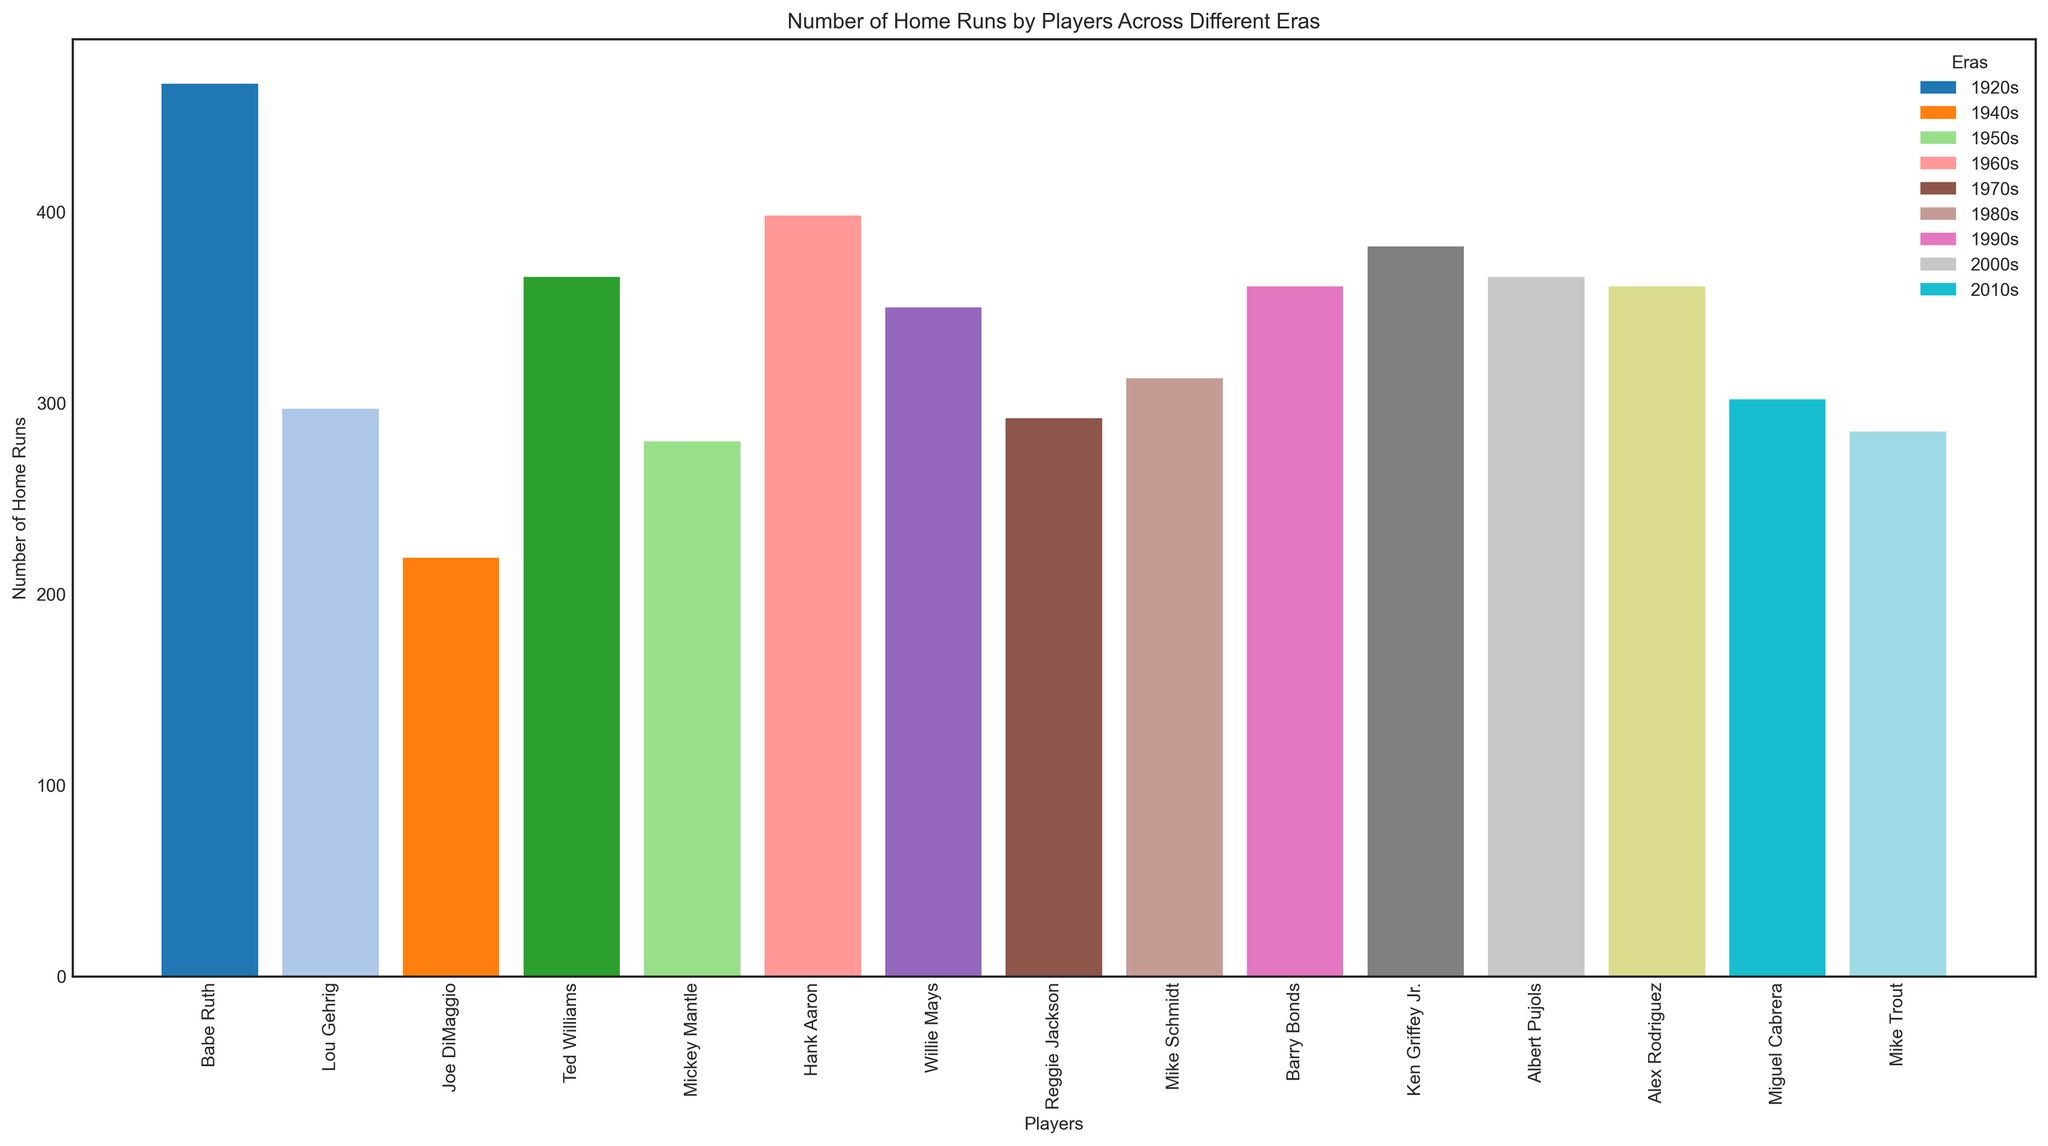Who had the highest number of home runs in the 1920s? To identify the player with the highest number of home runs in the 1920s, we can look at the bars related to Babe Ruth and Lou Gehrig. Babe Ruth clearly has a taller bar with 467 home runs compared to Lou Gehrig's 297 home runs.
Answer: Babe Ruth What is the combined number of home runs for players in the 2000s? To find the combined number of home runs for the 2000s, sum the home runs of Albert Pujols (366) and Alex Rodriguez (361). The calculation is 366 + 361.
Answer: 727 Which player from the 1990s has more home runs, Barry Bonds or Ken Griffey Jr.? Comparing the heights of the bars for Barry Bonds and Ken Griffey Jr., Ken Griffey Jr.'s bar is taller, indicating he has more home runs (382) compared to Barry Bonds (361).
Answer: Ken Griffey Jr What is the average number of home runs for players in the 2010s? To calculate the average number of home runs for the 2010s, sum the home runs of Miguel Cabrera (302) and Mike Trout (285), then divide by 2. The calculation is (302 + 285) / 2.
Answer: 293.5 How many more home runs did Hank Aaron hit compared to Reggie Jackson? Calculate the difference in home runs between Hank Aaron (398) and Reggie Jackson (292). The calculation is 398 - 292.
Answer: 106 Which era has the player with the maximum number of home runs overall? Observing the tallest bar in the entire plot, Babe Ruth from the 1920s has the maximum number of home runs overall with 467.
Answer: 1920s Do players from the 1960s hit more home runs in total compared to players from the 1950s and 1970s combined? First, sum the home runs of players from the 1960s (Hank Aaron: 398, Willie Mays: 350), giving 748. Then, sum the home runs from players in the 1950s (Mickey Mantle: 280) and the 1970s (Reggie Jackson: 292) combined, which is 280 + 292 = 572. Compare the totals 748 > 572.
Answer: Yes Who had more home runs: Lou Gehrig in the 1920s or Mike Trout in the 2010s? Compare the heights of the bars for Lou Gehrig (297) and Mike Trout (285). Lou Gehrig has a slightly taller bar.
Answer: Lou Gehrig What is the difference in the number of home runs between the player with the most and the player with the least home runs? Identify the player with the most home runs (Babe Ruth: 467) and the player with the least home runs (Joe DiMaggio: 219), then calculate the difference 467 - 219.
Answer: 248 